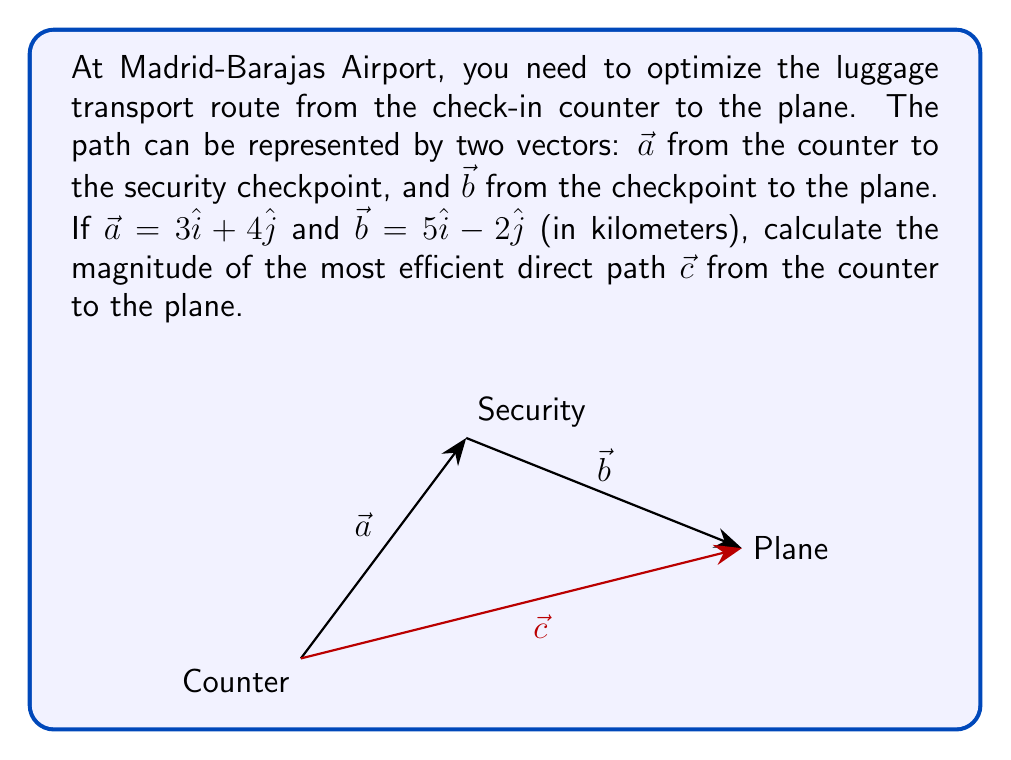Could you help me with this problem? Let's solve this step-by-step:

1) The most efficient direct path $\vec{c}$ is the vector sum of $\vec{a}$ and $\vec{b}$:

   $$\vec{c} = \vec{a} + \vec{b}$$

2) We can calculate this sum:
   
   $$\vec{c} = (3\hat{i} + 4\hat{j}) + (5\hat{i} - 2\hat{j})$$
   $$\vec{c} = (3+5)\hat{i} + (4-2)\hat{j}$$
   $$\vec{c} = 8\hat{i} + 2\hat{j}$$

3) To find the magnitude of $\vec{c}$, we use the Pythagorean theorem:

   $$|\vec{c}| = \sqrt{c_x^2 + c_y^2}$$

   Where $c_x = 8$ and $c_y = 2$

4) Substituting these values:

   $$|\vec{c}| = \sqrt{8^2 + 2^2}$$
   $$|\vec{c}| = \sqrt{64 + 4}$$
   $$|\vec{c}| = \sqrt{68}$$

5) Simplify:

   $$|\vec{c}| = 2\sqrt{17} \text{ km}$$

Thus, the magnitude of the most efficient direct path is $2\sqrt{17}$ kilometers.
Answer: $2\sqrt{17}$ km 